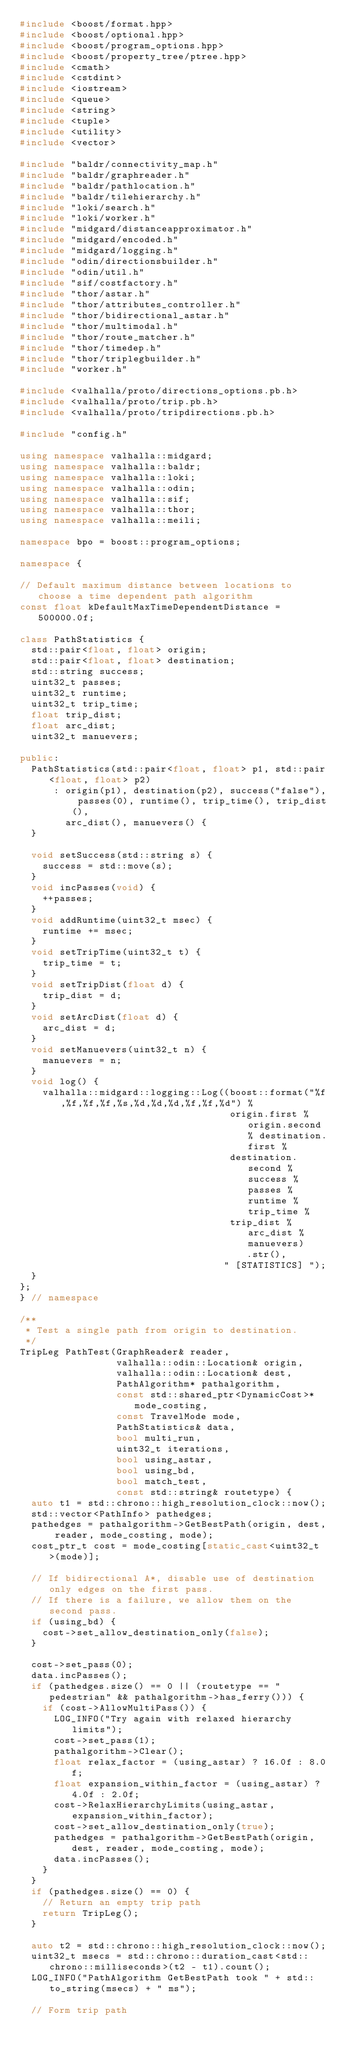<code> <loc_0><loc_0><loc_500><loc_500><_C++_>#include <boost/format.hpp>
#include <boost/optional.hpp>
#include <boost/program_options.hpp>
#include <boost/property_tree/ptree.hpp>
#include <cmath>
#include <cstdint>
#include <iostream>
#include <queue>
#include <string>
#include <tuple>
#include <utility>
#include <vector>

#include "baldr/connectivity_map.h"
#include "baldr/graphreader.h"
#include "baldr/pathlocation.h"
#include "baldr/tilehierarchy.h"
#include "loki/search.h"
#include "loki/worker.h"
#include "midgard/distanceapproximator.h"
#include "midgard/encoded.h"
#include "midgard/logging.h"
#include "odin/directionsbuilder.h"
#include "odin/util.h"
#include "sif/costfactory.h"
#include "thor/astar.h"
#include "thor/attributes_controller.h"
#include "thor/bidirectional_astar.h"
#include "thor/multimodal.h"
#include "thor/route_matcher.h"
#include "thor/timedep.h"
#include "thor/triplegbuilder.h"
#include "worker.h"

#include <valhalla/proto/directions_options.pb.h>
#include <valhalla/proto/trip.pb.h>
#include <valhalla/proto/tripdirections.pb.h>

#include "config.h"

using namespace valhalla::midgard;
using namespace valhalla::baldr;
using namespace valhalla::loki;
using namespace valhalla::odin;
using namespace valhalla::sif;
using namespace valhalla::thor;
using namespace valhalla::meili;

namespace bpo = boost::program_options;

namespace {

// Default maximum distance between locations to choose a time dependent path algorithm
const float kDefaultMaxTimeDependentDistance = 500000.0f;

class PathStatistics {
  std::pair<float, float> origin;
  std::pair<float, float> destination;
  std::string success;
  uint32_t passes;
  uint32_t runtime;
  uint32_t trip_time;
  float trip_dist;
  float arc_dist;
  uint32_t manuevers;

public:
  PathStatistics(std::pair<float, float> p1, std::pair<float, float> p2)
      : origin(p1), destination(p2), success("false"), passes(0), runtime(), trip_time(), trip_dist(),
        arc_dist(), manuevers() {
  }

  void setSuccess(std::string s) {
    success = std::move(s);
  }
  void incPasses(void) {
    ++passes;
  }
  void addRuntime(uint32_t msec) {
    runtime += msec;
  }
  void setTripTime(uint32_t t) {
    trip_time = t;
  }
  void setTripDist(float d) {
    trip_dist = d;
  }
  void setArcDist(float d) {
    arc_dist = d;
  }
  void setManuevers(uint32_t n) {
    manuevers = n;
  }
  void log() {
    valhalla::midgard::logging::Log((boost::format("%f,%f,%f,%f,%s,%d,%d,%d,%f,%f,%d") %
                                     origin.first % origin.second % destination.first %
                                     destination.second % success % passes % runtime % trip_time %
                                     trip_dist % arc_dist % manuevers)
                                        .str(),
                                    " [STATISTICS] ");
  }
};
} // namespace

/**
 * Test a single path from origin to destination.
 */
TripLeg PathTest(GraphReader& reader,
                 valhalla::odin::Location& origin,
                 valhalla::odin::Location& dest,
                 PathAlgorithm* pathalgorithm,
                 const std::shared_ptr<DynamicCost>* mode_costing,
                 const TravelMode mode,
                 PathStatistics& data,
                 bool multi_run,
                 uint32_t iterations,
                 bool using_astar,
                 bool using_bd,
                 bool match_test,
                 const std::string& routetype) {
  auto t1 = std::chrono::high_resolution_clock::now();
  std::vector<PathInfo> pathedges;
  pathedges = pathalgorithm->GetBestPath(origin, dest, reader, mode_costing, mode);
  cost_ptr_t cost = mode_costing[static_cast<uint32_t>(mode)];

  // If bidirectional A*, disable use of destination only edges on the first pass.
  // If there is a failure, we allow them on the second pass.
  if (using_bd) {
    cost->set_allow_destination_only(false);
  }

  cost->set_pass(0);
  data.incPasses();
  if (pathedges.size() == 0 || (routetype == "pedestrian" && pathalgorithm->has_ferry())) {
    if (cost->AllowMultiPass()) {
      LOG_INFO("Try again with relaxed hierarchy limits");
      cost->set_pass(1);
      pathalgorithm->Clear();
      float relax_factor = (using_astar) ? 16.0f : 8.0f;
      float expansion_within_factor = (using_astar) ? 4.0f : 2.0f;
      cost->RelaxHierarchyLimits(using_astar, expansion_within_factor);
      cost->set_allow_destination_only(true);
      pathedges = pathalgorithm->GetBestPath(origin, dest, reader, mode_costing, mode);
      data.incPasses();
    }
  }
  if (pathedges.size() == 0) {
    // Return an empty trip path
    return TripLeg();
  }

  auto t2 = std::chrono::high_resolution_clock::now();
  uint32_t msecs = std::chrono::duration_cast<std::chrono::milliseconds>(t2 - t1).count();
  LOG_INFO("PathAlgorithm GetBestPath took " + std::to_string(msecs) + " ms");

  // Form trip path</code> 